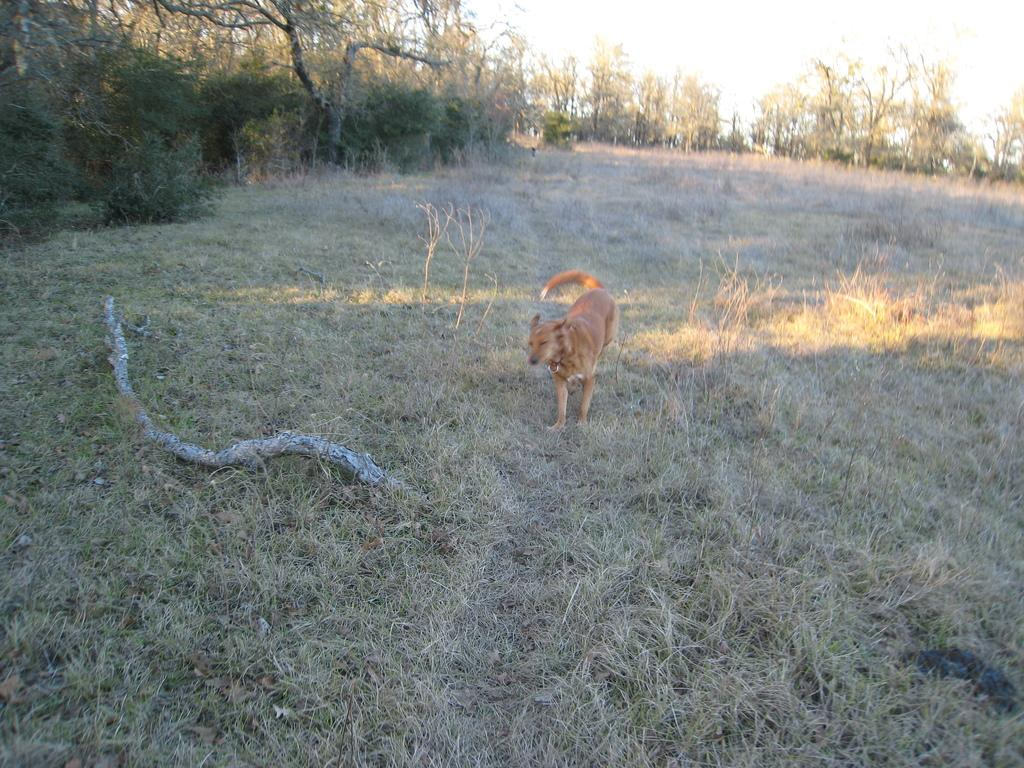What type of animal is in the image? There is a dog in the image. Where is the dog located? The dog is on the ground. What can be seen in the background of the image? There are trees in the background of the image. What object is beside the dog? There is a wooden stick beside the dog. What type of surface is the dog standing on? There is grass on the ground. What type of fowl can be seen perched on the dog's head in the image? There is no fowl present in the image, and the dog's head is not occupied by any animal. 